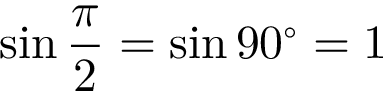Convert formula to latex. <formula><loc_0><loc_0><loc_500><loc_500>\sin { \frac { \pi } { 2 } } = \sin 9 0 ^ { \circ } = 1</formula> 